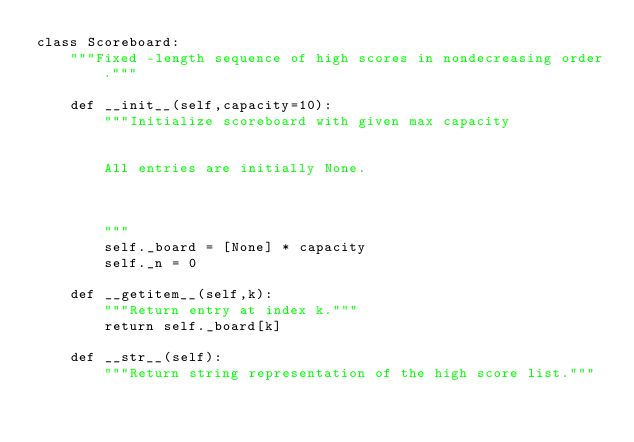<code> <loc_0><loc_0><loc_500><loc_500><_Python_>class Scoreboard:
    """Fixed -length sequence of high scores in nondecreasing order."""

    def __init__(self,capacity=10):
        """Initialize scoreboard with given max capacity


        All entries are initially None.



        """
        self._board = [None] * capacity
        self._n = 0

    def __getitem__(self,k):
        """Return entry at index k."""
        return self._board[k]

    def __str__(self):
        """Return string representation of the high score list."""</code> 